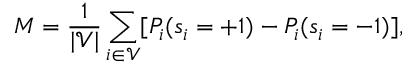<formula> <loc_0><loc_0><loc_500><loc_500>M = \frac { 1 } { | \mathcal { V } | } \sum _ { i \in \mathcal { V } } [ P _ { i } ( s _ { i } = + 1 ) - P _ { i } ( s _ { i } = - 1 ) ] ,</formula> 